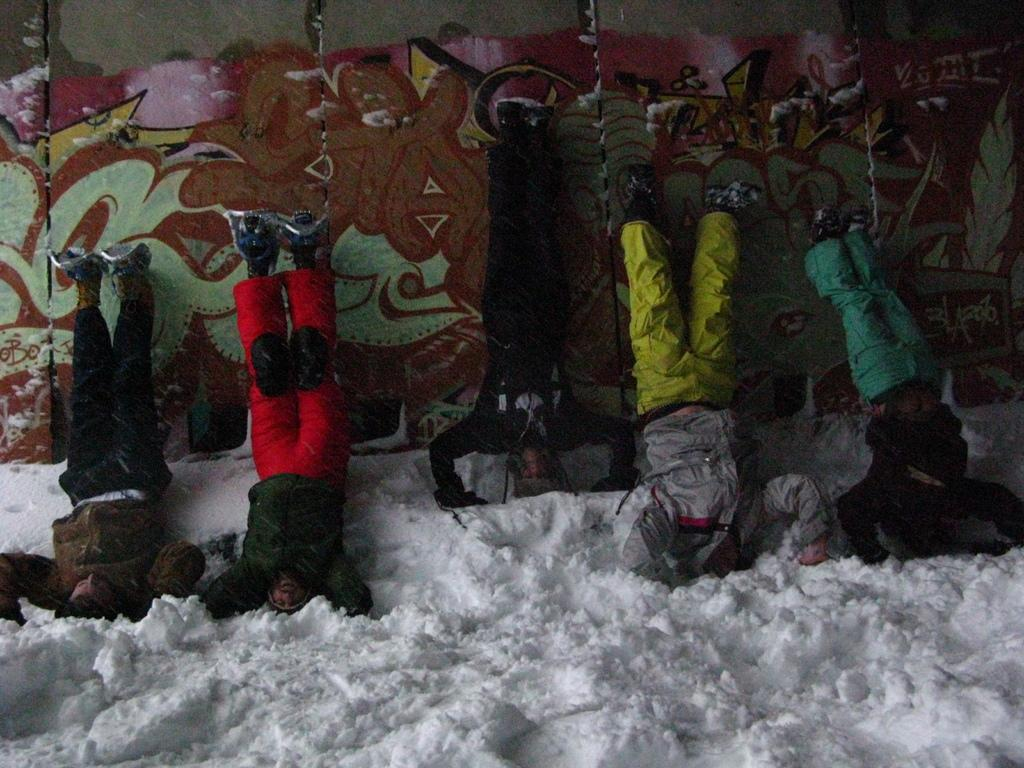What is the ground made of at the bottom of the image? There is snow at the bottom of the image. What can be seen in the middle of the image? There are people in the middle of the image. What are the people doing in the image? The people are doing something, but we need more information to determine what specific activity they are engaged in. What is visible in the background of the image? There is a wall in the background of the image. What type of sign can be seen in the image? There is no sign present in the image; it features snow, people, and a wall. What is the reaction of the people to the bomb in the image? There is no bomb present in the image, so there is no reaction to it. 